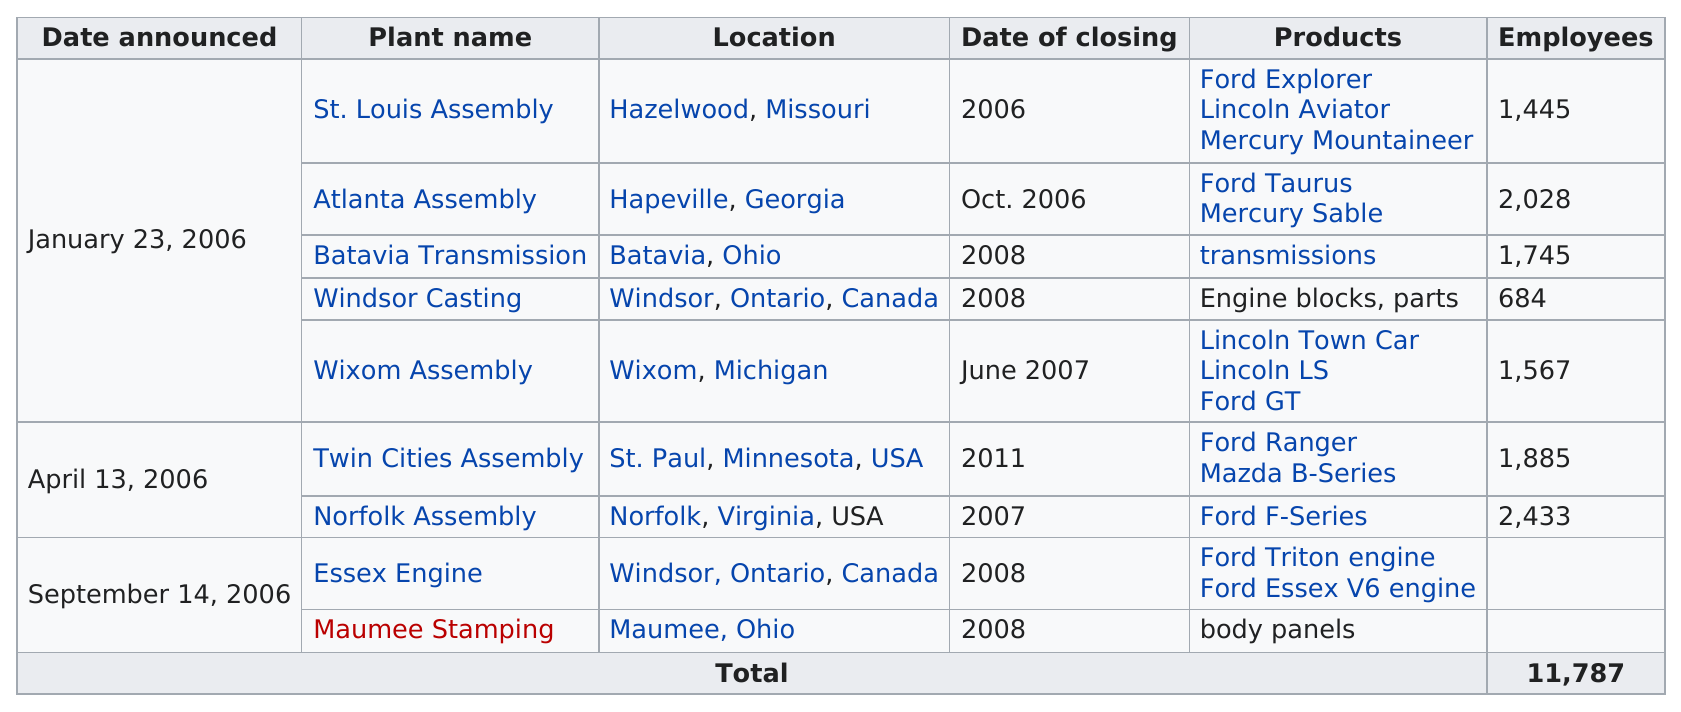Mention a couple of crucial points in this snapshot. The Atlanta Assembly did not have 1000 employees above the St. Louis Assembly. The St. Louis Assembly plant is listed first among the plants listed. Norfolk Assembly has the most employees among the plants that are closing. There are approximately 2 plants in Ohio. A large number of plants had more than 2000 employees laid off. 